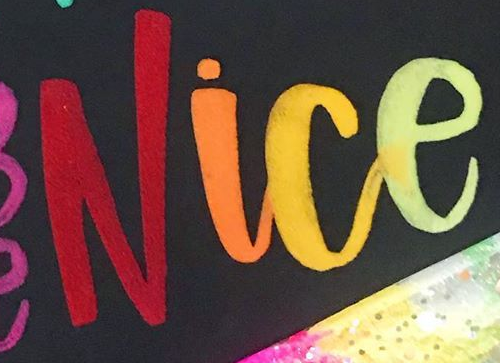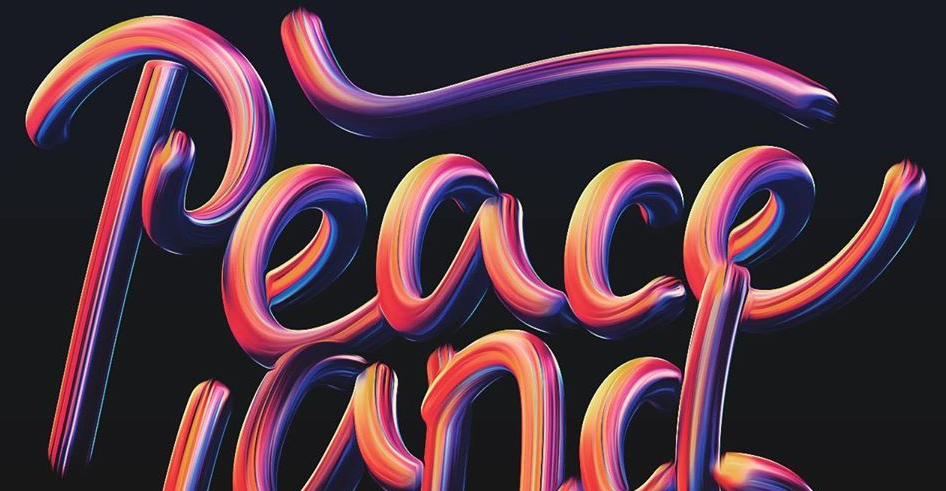What text is displayed in these images sequentially, separated by a semicolon? Nice; Peace 